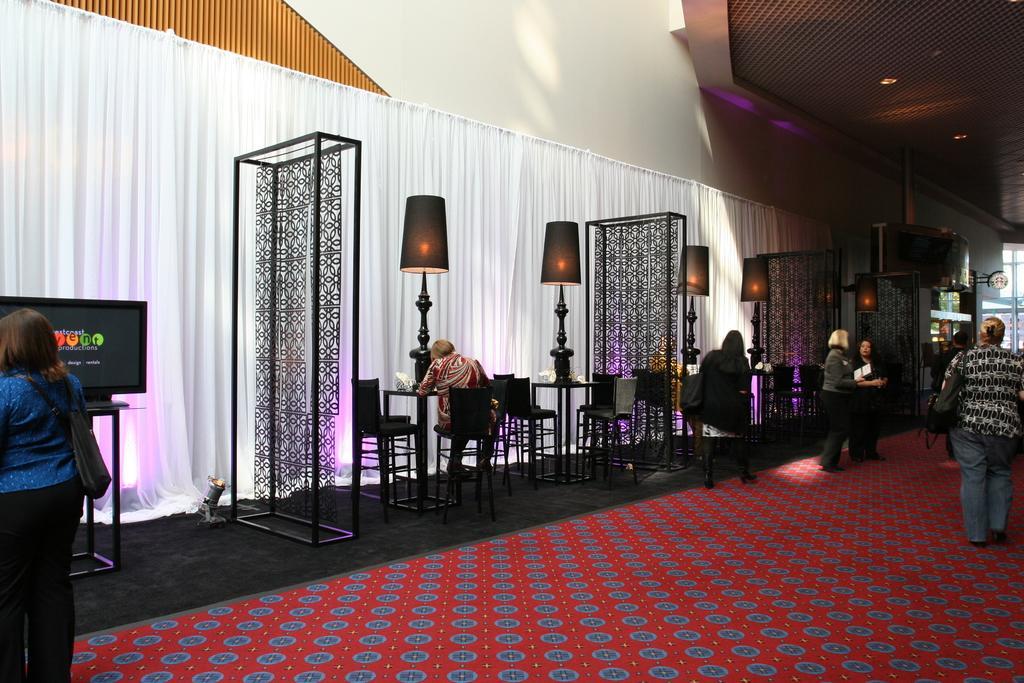How would you summarize this image in a sentence or two? In the image I can see some people sitting on the chairs around the table on which there are some lamps and also I can see some hangings to the stand and some screens and people around. 